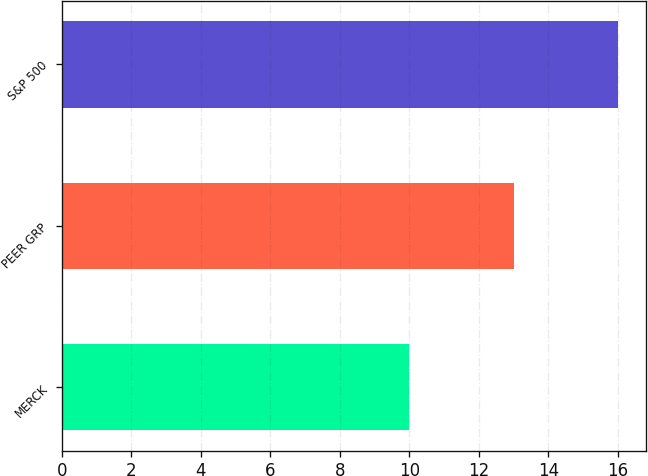Convert chart. <chart><loc_0><loc_0><loc_500><loc_500><bar_chart><fcel>MERCK<fcel>PEER GRP<fcel>S&P 500<nl><fcel>10<fcel>13<fcel>16<nl></chart> 